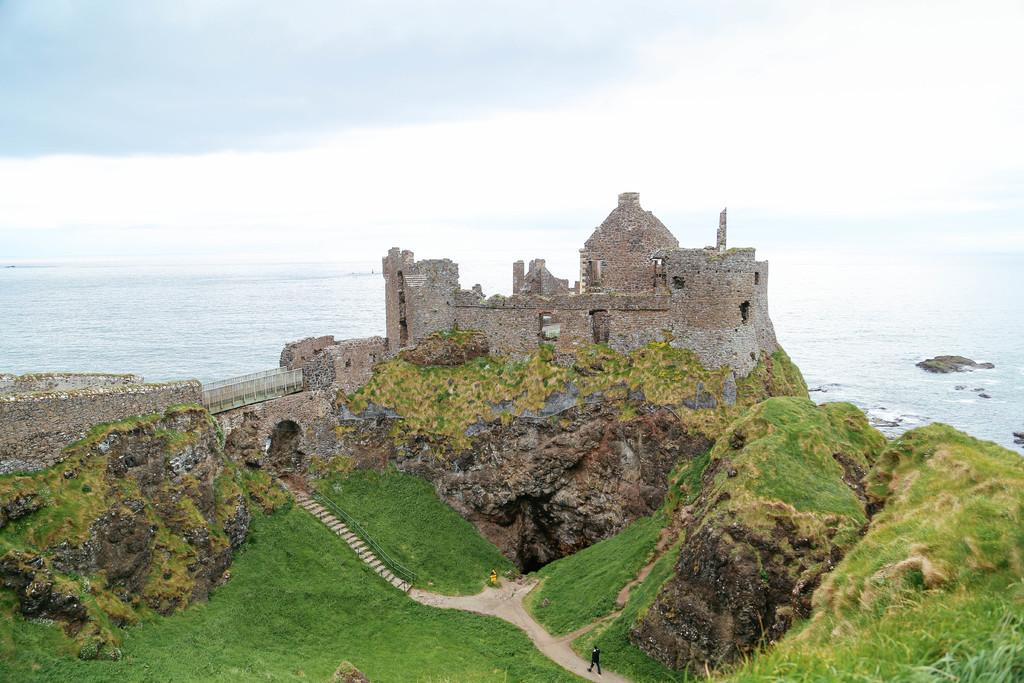What type of vegetation is present in the image? There is grass in the image. What is the man in the image doing? There is a man walking in the image. What type of structure can be seen in the image? There is a building in the image. What architectural feature is present in the image? There is a bridge in the image. What natural element is visible in the image? There is water visible in the image. What can be seen in the background of the image? The sky is visible in the background of the image. What type of music can be heard playing in the background of the image? There is no music present in the image, as it is a visual representation and does not include sound. 